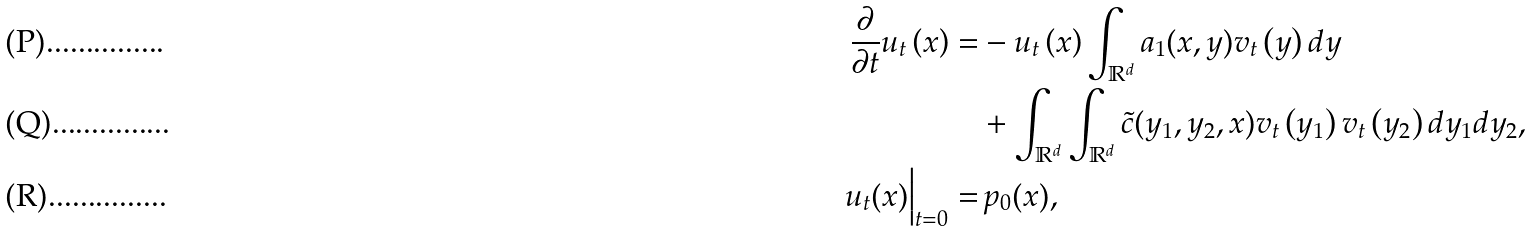<formula> <loc_0><loc_0><loc_500><loc_500>\frac { \partial } { \partial t } u _ { t } \left ( x \right ) = & - u _ { t } \left ( x \right ) \int _ { \mathbb { R } ^ { d } } a _ { 1 } ( x , y ) v _ { t } \left ( y \right ) d y \\ & + \int _ { \mathbb { R } ^ { d } } \int _ { \mathbb { R } ^ { d } } \tilde { c } ( y _ { 1 } , y _ { 2 } , x ) v _ { t } \left ( y _ { 1 } \right ) v _ { t } \left ( y _ { 2 } \right ) d y _ { 1 } d y _ { 2 } , \\ u _ { t } ( x ) \Big | _ { t = 0 } = & \, p _ { 0 } ( x ) ,</formula> 